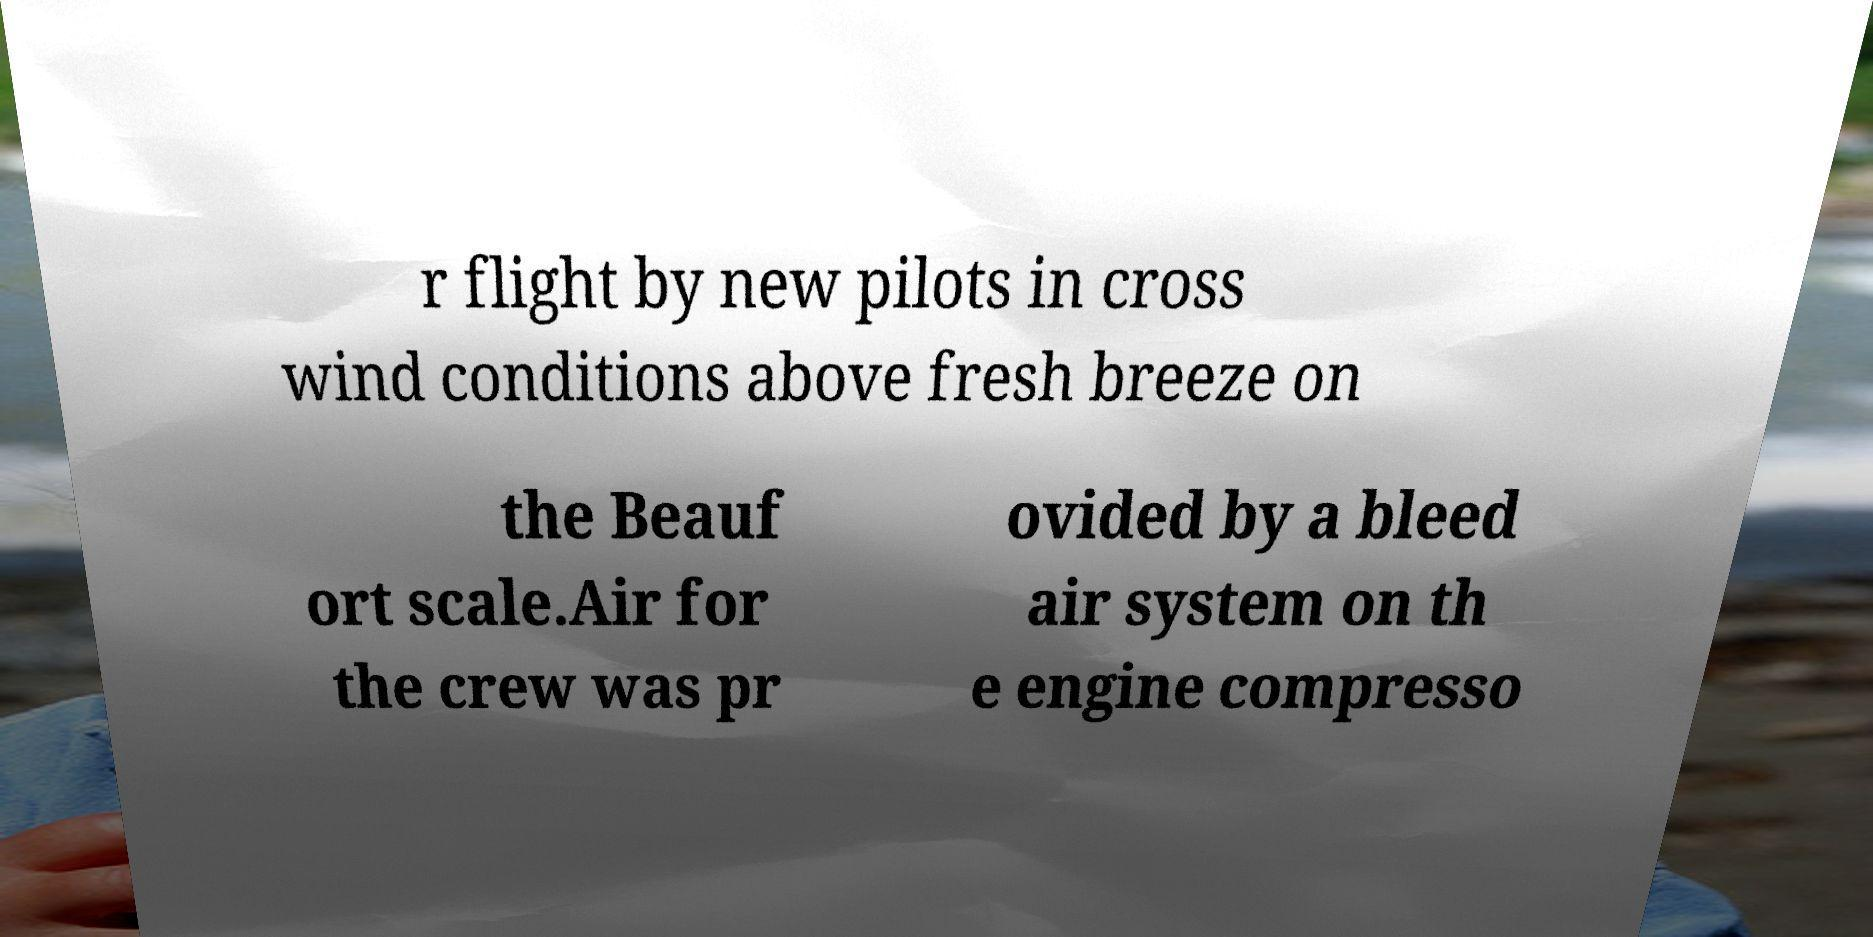Can you read and provide the text displayed in the image?This photo seems to have some interesting text. Can you extract and type it out for me? r flight by new pilots in cross wind conditions above fresh breeze on the Beauf ort scale.Air for the crew was pr ovided by a bleed air system on th e engine compresso 